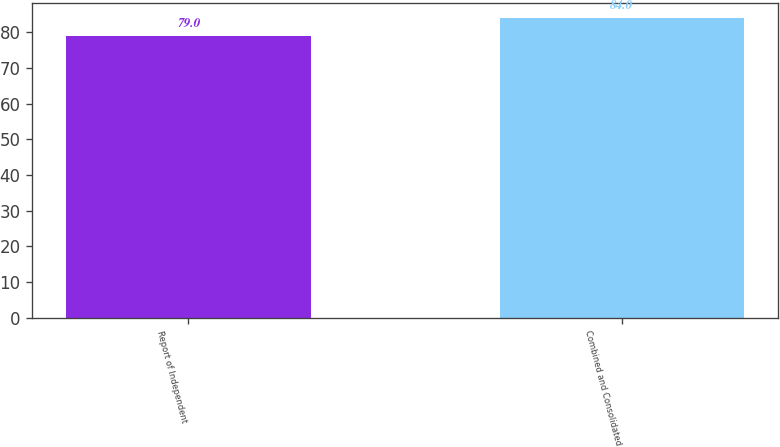Convert chart. <chart><loc_0><loc_0><loc_500><loc_500><bar_chart><fcel>Report of Independent<fcel>Combined and Consolidated<nl><fcel>79<fcel>84<nl></chart> 